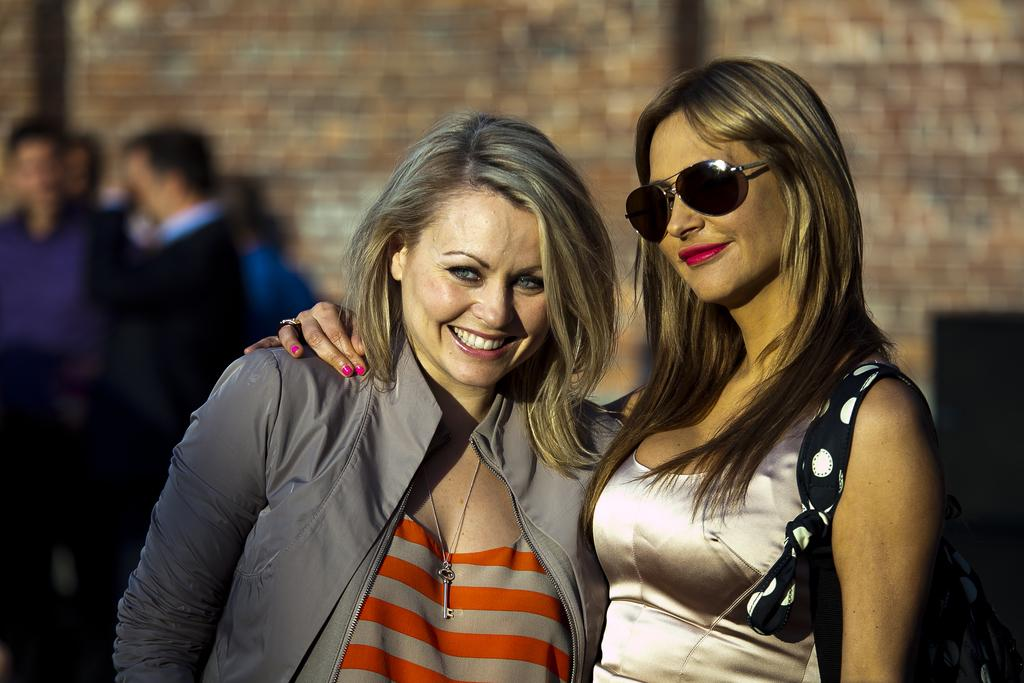How many people are in the image? There are people in the image. Can you describe any specific features of one of the people? One person is wearing spectacles. What can be observed about the background of the image? The background of the image is blurred. What date is circled on the calendar in the image? There is no calendar present in the image. How does the clam feel about being in the image? There is no clam present in the image, so it cannot have feelings about being in the image. 